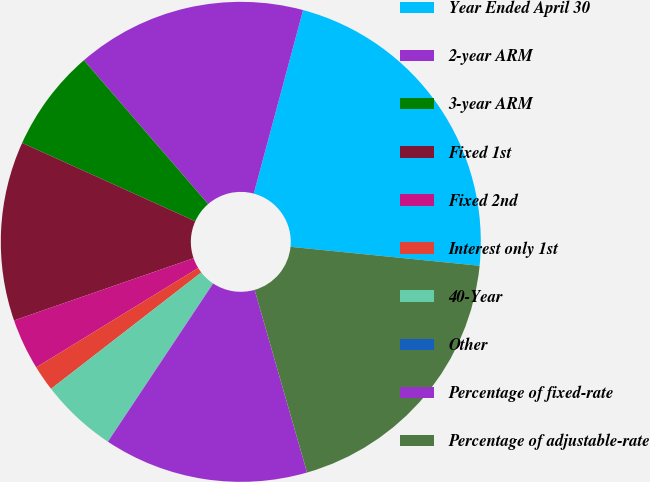Convert chart to OTSL. <chart><loc_0><loc_0><loc_500><loc_500><pie_chart><fcel>Year Ended April 30<fcel>2-year ARM<fcel>3-year ARM<fcel>Fixed 1st<fcel>Fixed 2nd<fcel>Interest only 1st<fcel>40-Year<fcel>Other<fcel>Percentage of fixed-rate<fcel>Percentage of adjustable-rate<nl><fcel>22.41%<fcel>15.52%<fcel>6.9%<fcel>12.07%<fcel>3.45%<fcel>1.73%<fcel>5.17%<fcel>0.0%<fcel>13.79%<fcel>18.96%<nl></chart> 